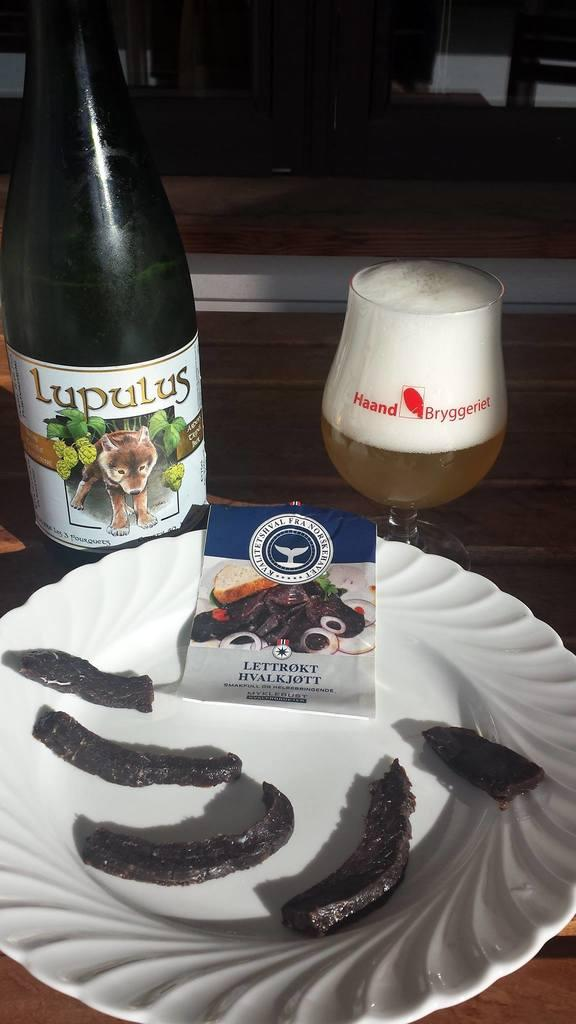What is on the plate that is visible in the image? There is food on a plate in the image. Where is the plate located in the image? The plate is in the center of the image. What is the bottle with text on it used for? The bottle with text on it is likely used for holding a liquid, such as a beverage. Where is the glass with text on it located in the image? The glass with text on it is not mentioned as being on the plate, so its location is not specified. How many frogs are sitting on the crown in the image? There is no crown or frogs present in the image. 